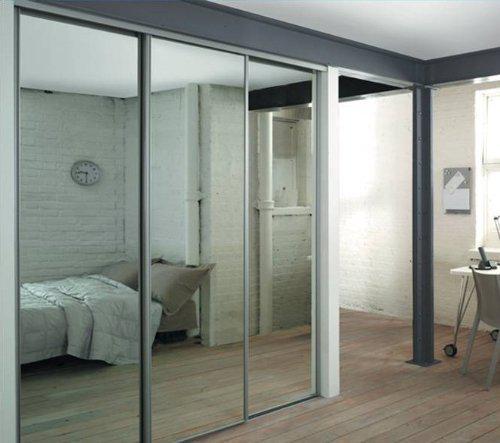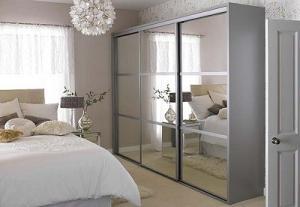The first image is the image on the left, the second image is the image on the right. Evaluate the accuracy of this statement regarding the images: "In each room there are mirrored sliding doors on the closet.". Is it true? Answer yes or no. Yes. 